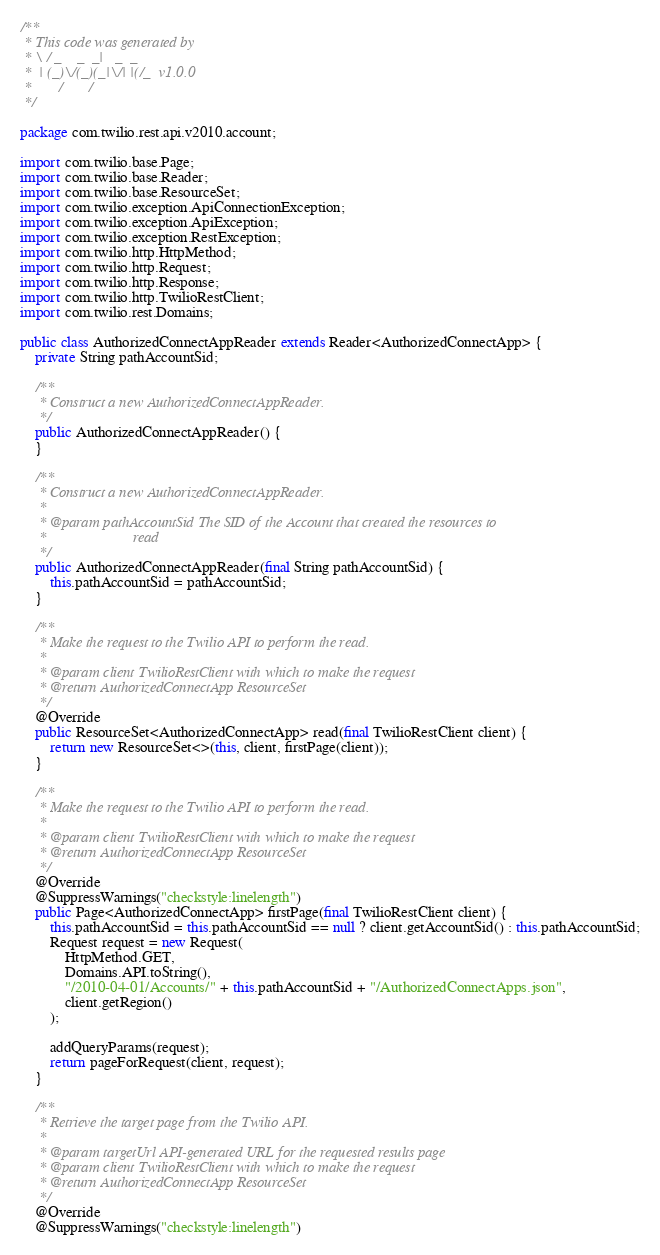Convert code to text. <code><loc_0><loc_0><loc_500><loc_500><_Java_>/**
 * This code was generated by
 * \ / _    _  _|   _  _
 *  | (_)\/(_)(_|\/| |(/_  v1.0.0
 *       /       /
 */

package com.twilio.rest.api.v2010.account;

import com.twilio.base.Page;
import com.twilio.base.Reader;
import com.twilio.base.ResourceSet;
import com.twilio.exception.ApiConnectionException;
import com.twilio.exception.ApiException;
import com.twilio.exception.RestException;
import com.twilio.http.HttpMethod;
import com.twilio.http.Request;
import com.twilio.http.Response;
import com.twilio.http.TwilioRestClient;
import com.twilio.rest.Domains;

public class AuthorizedConnectAppReader extends Reader<AuthorizedConnectApp> {
    private String pathAccountSid;

    /**
     * Construct a new AuthorizedConnectAppReader.
     */
    public AuthorizedConnectAppReader() {
    }

    /**
     * Construct a new AuthorizedConnectAppReader.
     *
     * @param pathAccountSid The SID of the Account that created the resources to
     *                       read
     */
    public AuthorizedConnectAppReader(final String pathAccountSid) {
        this.pathAccountSid = pathAccountSid;
    }

    /**
     * Make the request to the Twilio API to perform the read.
     *
     * @param client TwilioRestClient with which to make the request
     * @return AuthorizedConnectApp ResourceSet
     */
    @Override
    public ResourceSet<AuthorizedConnectApp> read(final TwilioRestClient client) {
        return new ResourceSet<>(this, client, firstPage(client));
    }

    /**
     * Make the request to the Twilio API to perform the read.
     *
     * @param client TwilioRestClient with which to make the request
     * @return AuthorizedConnectApp ResourceSet
     */
    @Override
    @SuppressWarnings("checkstyle:linelength")
    public Page<AuthorizedConnectApp> firstPage(final TwilioRestClient client) {
        this.pathAccountSid = this.pathAccountSid == null ? client.getAccountSid() : this.pathAccountSid;
        Request request = new Request(
            HttpMethod.GET,
            Domains.API.toString(),
            "/2010-04-01/Accounts/" + this.pathAccountSid + "/AuthorizedConnectApps.json",
            client.getRegion()
        );

        addQueryParams(request);
        return pageForRequest(client, request);
    }

    /**
     * Retrieve the target page from the Twilio API.
     *
     * @param targetUrl API-generated URL for the requested results page
     * @param client TwilioRestClient with which to make the request
     * @return AuthorizedConnectApp ResourceSet
     */
    @Override
    @SuppressWarnings("checkstyle:linelength")</code> 